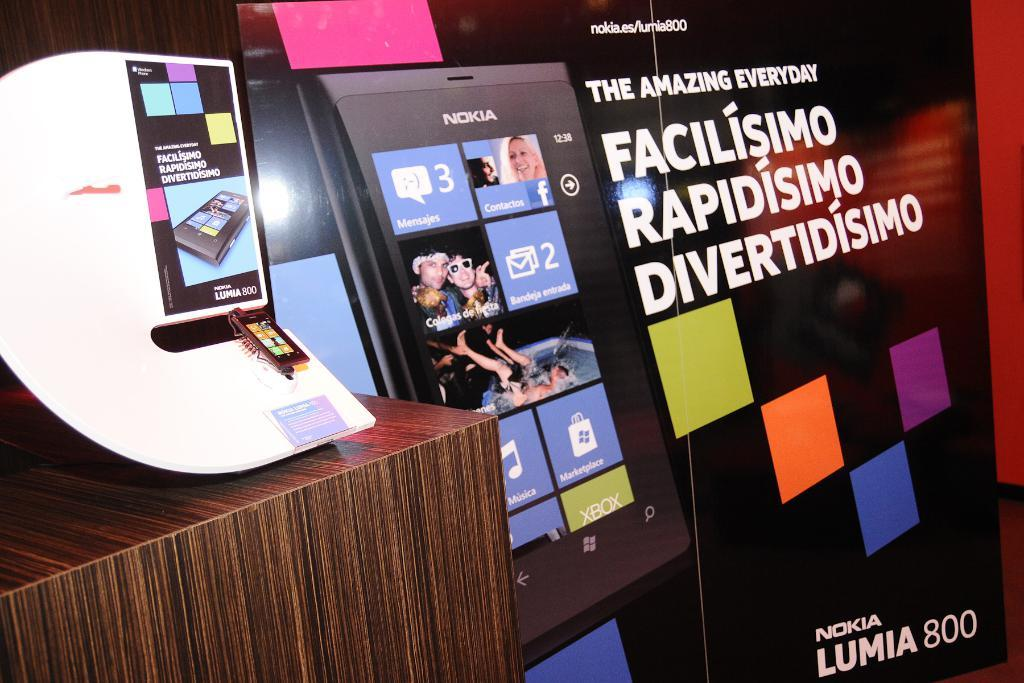<image>
Relay a brief, clear account of the picture shown. a display of the Nokia cell phone reads The Amazing Everyday 